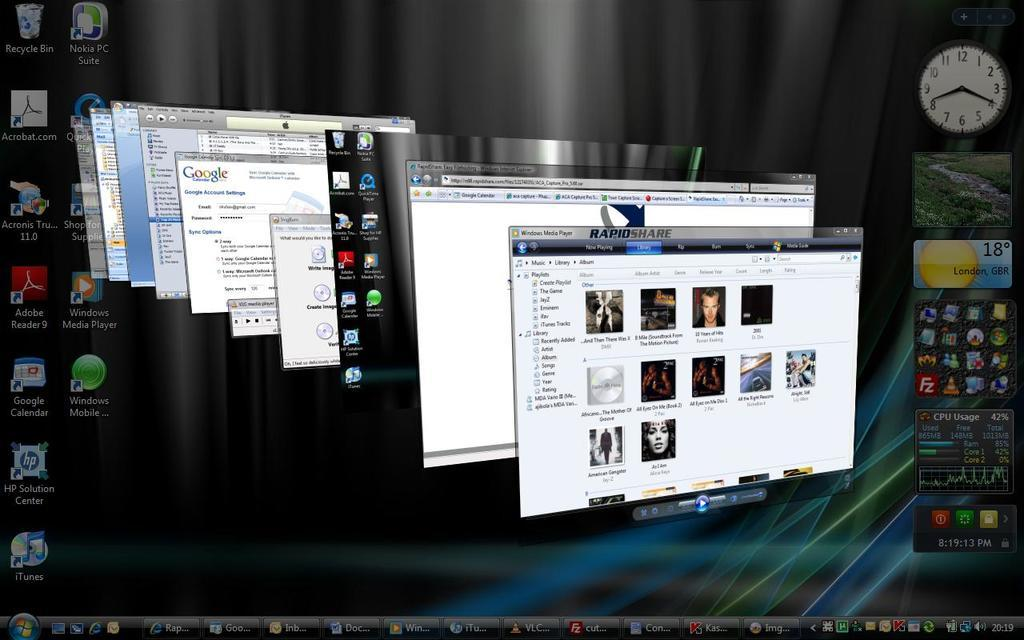<image>
Write a terse but informative summary of the picture. A computer screen with many windows open including Windows Media Player. 